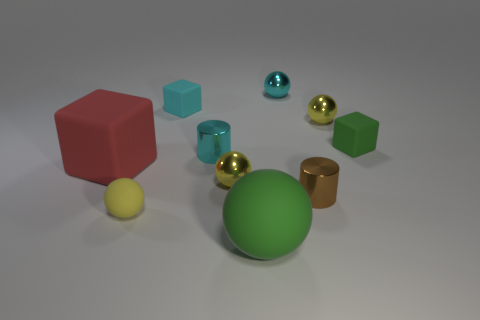Subtract all cyan cylinders. How many yellow balls are left? 3 Subtract all tiny yellow matte spheres. How many spheres are left? 4 Subtract 2 balls. How many balls are left? 3 Subtract all green spheres. How many spheres are left? 4 Subtract all red spheres. Subtract all red cylinders. How many spheres are left? 5 Subtract all cylinders. How many objects are left? 8 Add 6 matte blocks. How many matte blocks are left? 9 Add 9 big blue shiny cylinders. How many big blue shiny cylinders exist? 9 Subtract 1 brown cylinders. How many objects are left? 9 Subtract all large cyan metal blocks. Subtract all cyan balls. How many objects are left? 9 